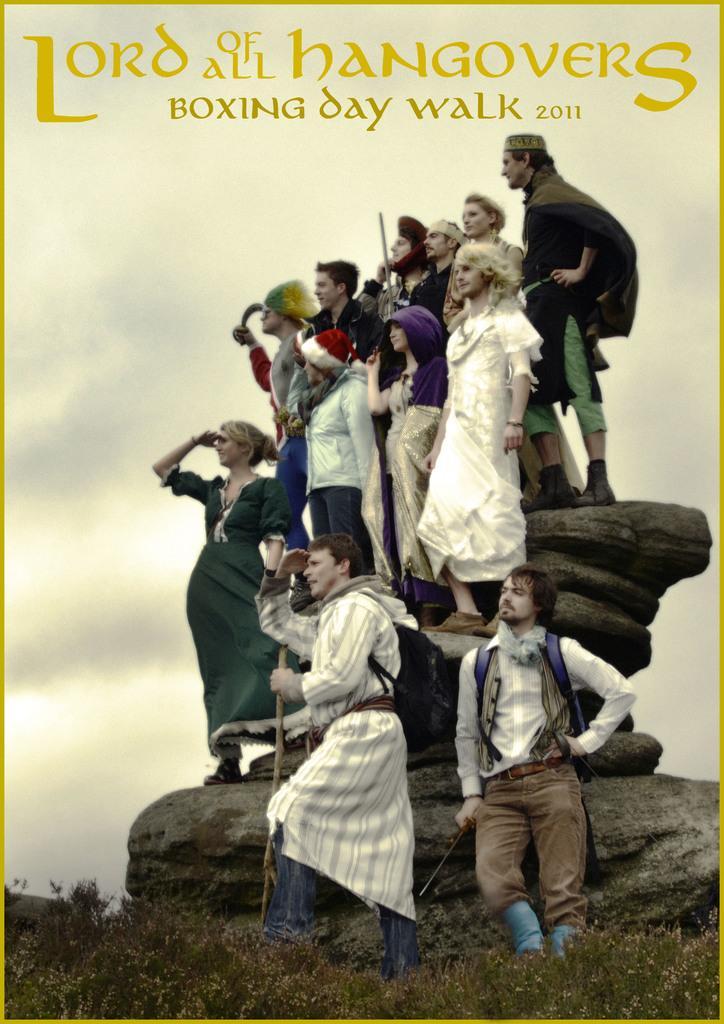How would you summarize this image in a sentence or two? This is a picture of a poster, where there are group of people standing on the rocks ,and there is grass, sky , and there are words and numbers on the poster. 